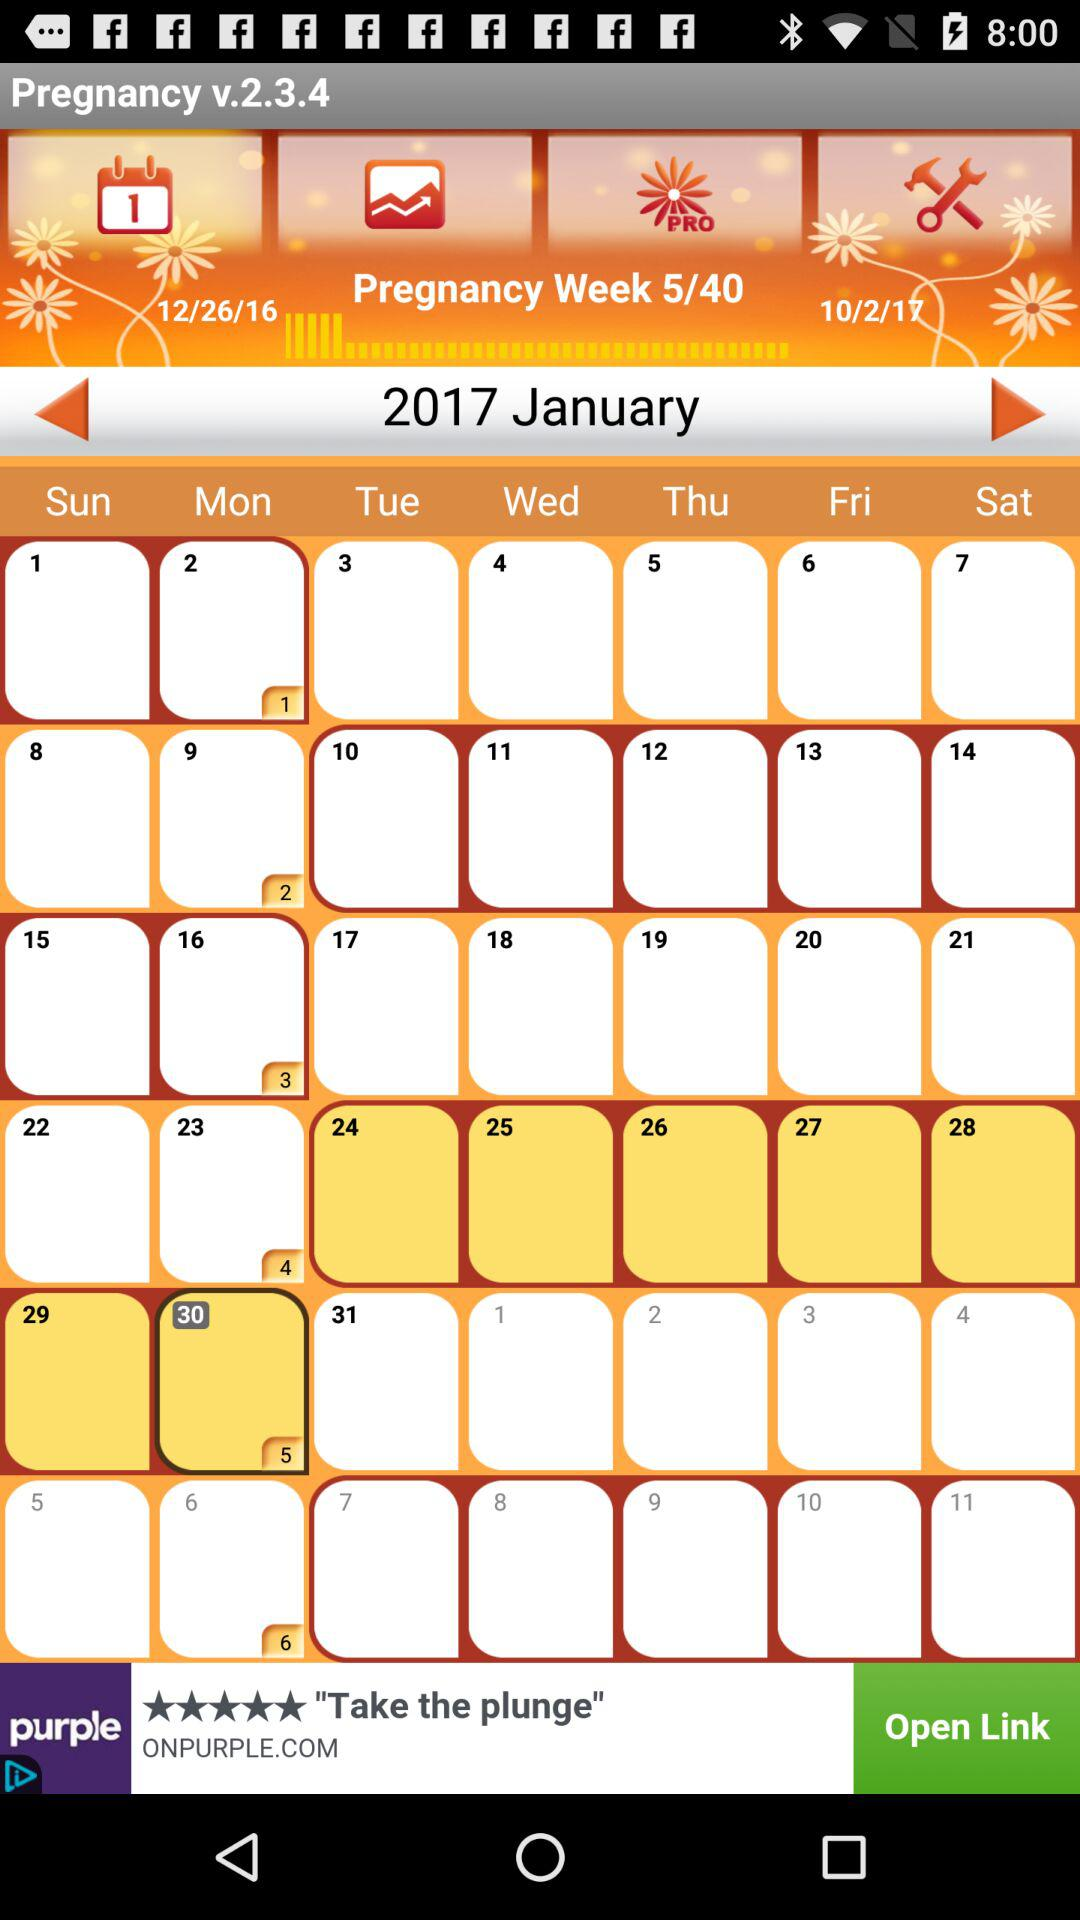Which is the current week of pregnancy out of the total week? The current week of pregnancy is week 5. 